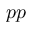<formula> <loc_0><loc_0><loc_500><loc_500>p p</formula> 